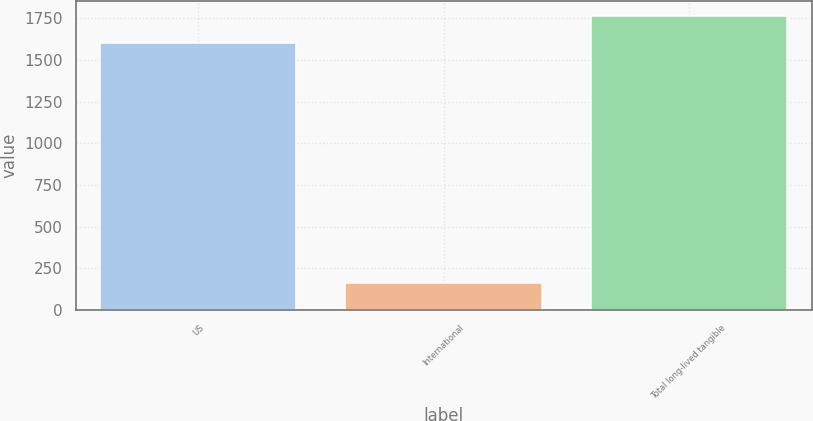<chart> <loc_0><loc_0><loc_500><loc_500><bar_chart><fcel>US<fcel>International<fcel>Total long-lived tangible<nl><fcel>1603<fcel>160<fcel>1763.3<nl></chart> 